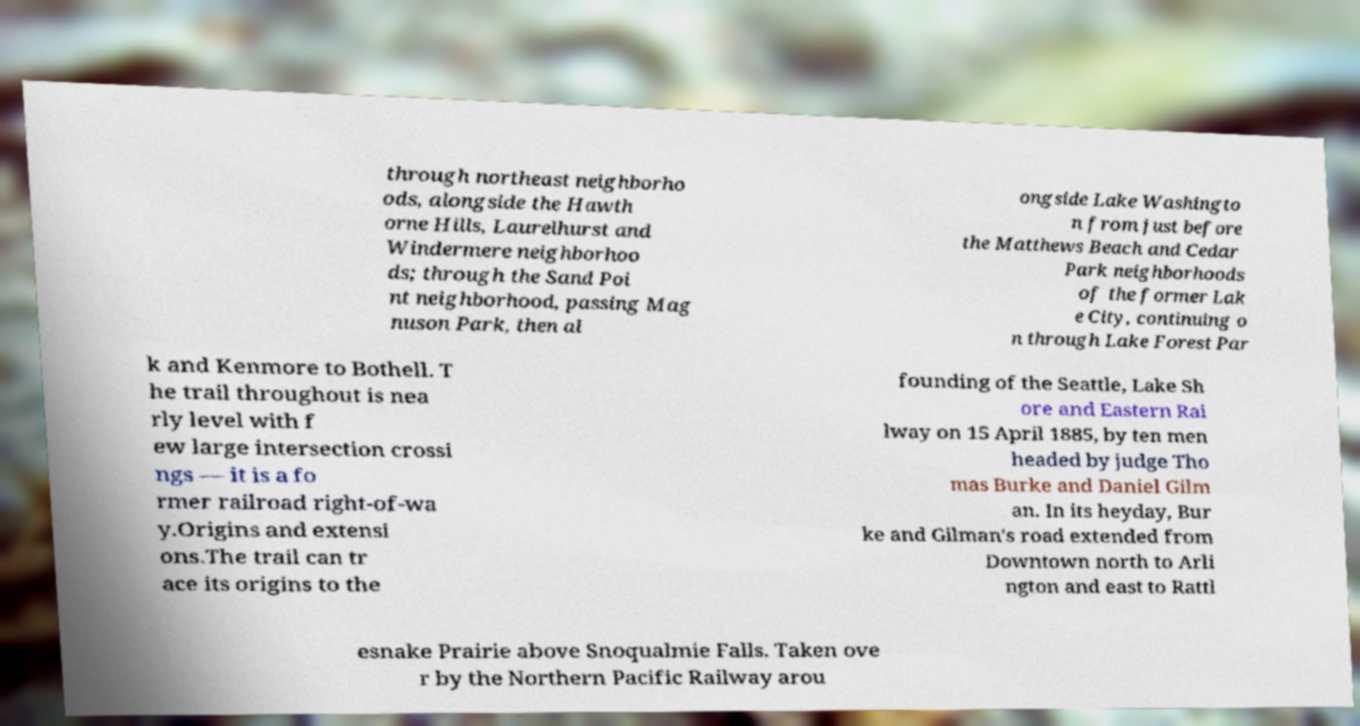Please identify and transcribe the text found in this image. through northeast neighborho ods, alongside the Hawth orne Hills, Laurelhurst and Windermere neighborhoo ds; through the Sand Poi nt neighborhood, passing Mag nuson Park, then al ongside Lake Washingto n from just before the Matthews Beach and Cedar Park neighborhoods of the former Lak e City, continuing o n through Lake Forest Par k and Kenmore to Bothell. T he trail throughout is nea rly level with f ew large intersection crossi ngs — it is a fo rmer railroad right-of-wa y.Origins and extensi ons.The trail can tr ace its origins to the founding of the Seattle, Lake Sh ore and Eastern Rai lway on 15 April 1885, by ten men headed by judge Tho mas Burke and Daniel Gilm an. In its heyday, Bur ke and Gilman's road extended from Downtown north to Arli ngton and east to Rattl esnake Prairie above Snoqualmie Falls. Taken ove r by the Northern Pacific Railway arou 